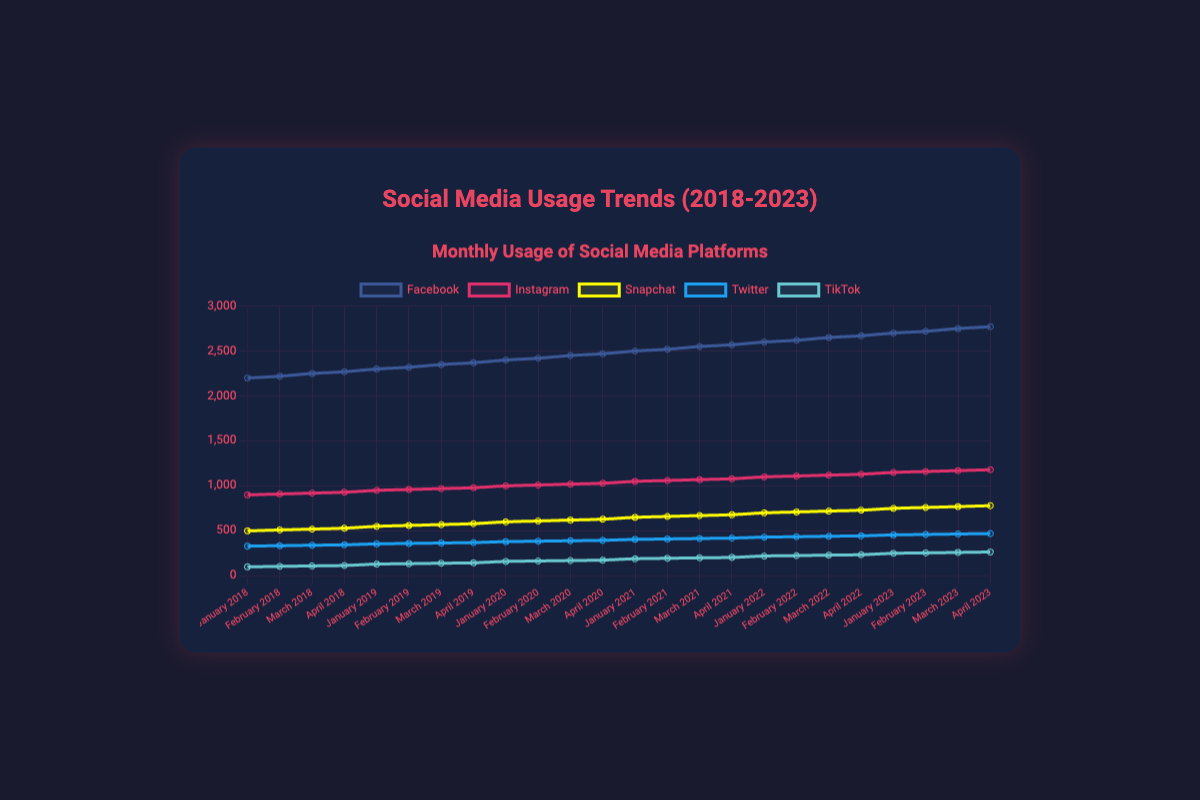What social media platform had the highest usage in January 2023? Look for the highest value in January 2023 among all platforms. Facebook had 2700, Instagram 1150, Snapchat 750, Twitter 455, and TikTok 250. Facebook has the highest usage.
Answer: Facebook How much did TikTok's usage increase from January 2018 to January 2023? Subtract TikTok's January 2018 usage (100) from January 2023 usage (250). 250 - 100 = 150
Answer: 150 Which platform had a higher usage in April 2020, Snapchat or Twitter? Compare Snapchat's April 2020 usage (630) with Twitter's April 2020 usage (395). Snapchat is higher.
Answer: Snapchat What was the sum of Instagram's usage for all months in 2019? Add Instagram's usage for January (950), February (960), March (970), and April (980) in 2019. 950 + 960 + 970 + 980 = 3860
Answer: 3860 Which platform showed the largest overall increase from January 2018 to April 2023? Calculate the difference between the values in January 2018 and April 2023 for each platform: Facebook: (2770-2200) = 570, Instagram: (1180-900) = 280, Snapchat: (780-500) = 280, Twitter: (470-330) = 140, TikTok: (265-100) = 165. Facebook has the largest increase.
Answer: Facebook How did the usage of Twitter change from January to April 2021? Subtract Twitter's January 2021 usage (405) from April 2021 usage (420). 420 - 405 = 15
Answer: Increased by 15 Which platform's usage remained under 500 until 2022? Analyze the data points for each platform until 2022. TikTok remained under 500 until 2022.
Answer: TikTok What is the average monthly usage of Snapchat in 2020? Add the Snapchat values for each month in 2020 (600, 610, 620, 630) and divide by the number of months. (600 + 610 + 620 + 630) / 4 = 615
Answer: 615 Which platform has the most consistent trend over the five years? Examine the trends of each platform. Facebook shows a consistent upward trend year over year without significant fluctuations.
Answer: Facebook 